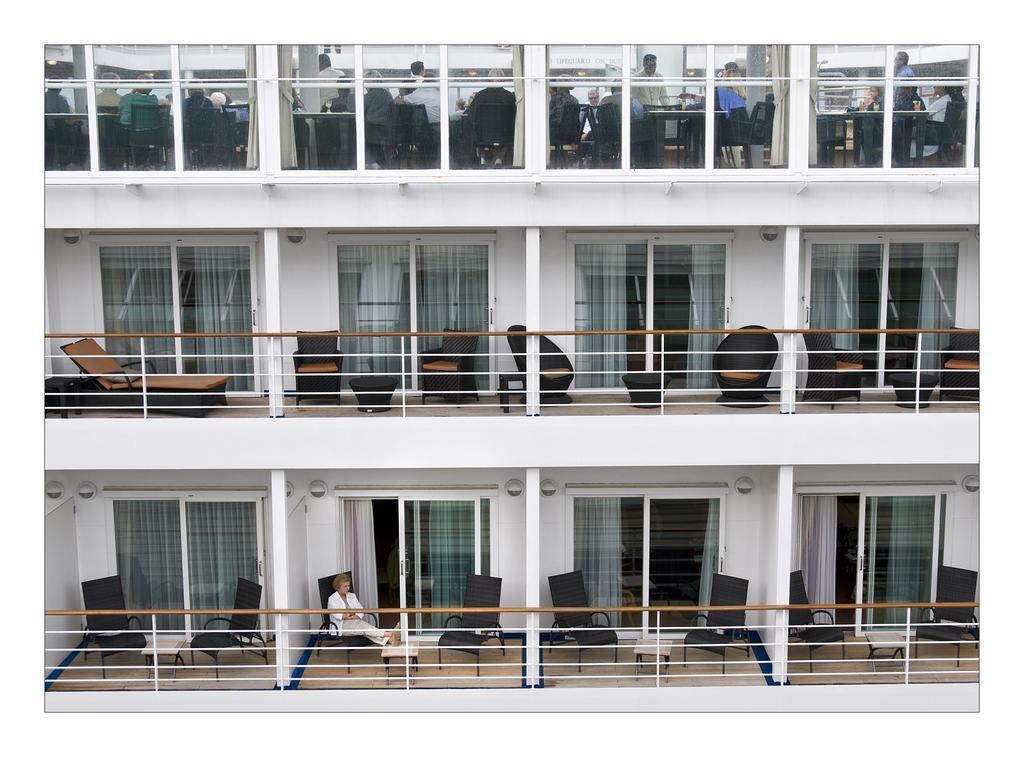In one or two sentences, can you explain what this image depicts? There is a white color building which has few chairs and few people sitting in it. 